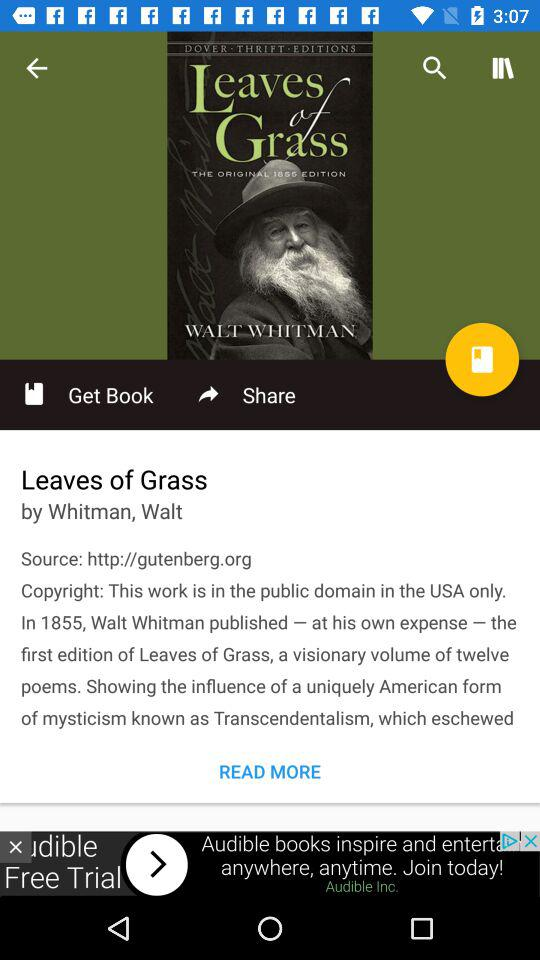What is the publication year of the book "Leaves of Grass"? The publication year is 1855. 